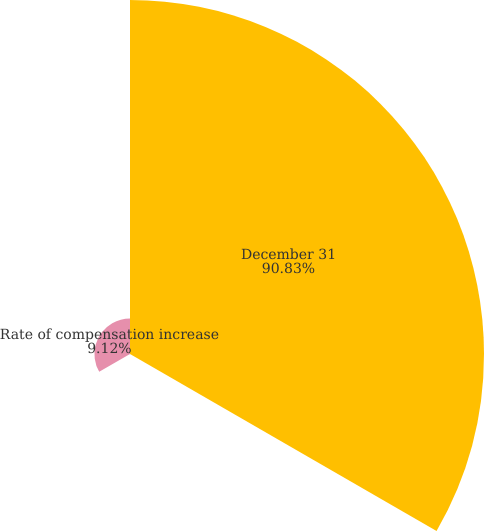<chart> <loc_0><loc_0><loc_500><loc_500><pie_chart><fcel>December 31<fcel>Rates of compensation increase<fcel>Rate of compensation increase<nl><fcel>90.83%<fcel>0.05%<fcel>9.12%<nl></chart> 